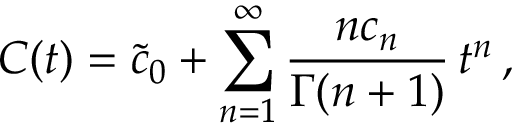<formula> <loc_0><loc_0><loc_500><loc_500>C ( t ) = { \tilde { c } _ { 0 } } + \sum _ { n = 1 } ^ { \infty } \frac { n c _ { n } } { \Gamma ( n + 1 ) } \, t ^ { n } \, ,</formula> 